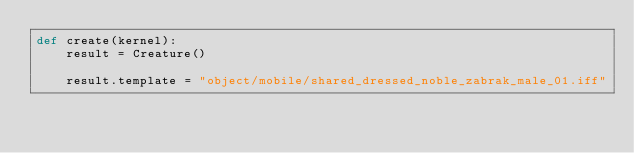Convert code to text. <code><loc_0><loc_0><loc_500><loc_500><_Python_>def create(kernel):
	result = Creature()

	result.template = "object/mobile/shared_dressed_noble_zabrak_male_01.iff"</code> 